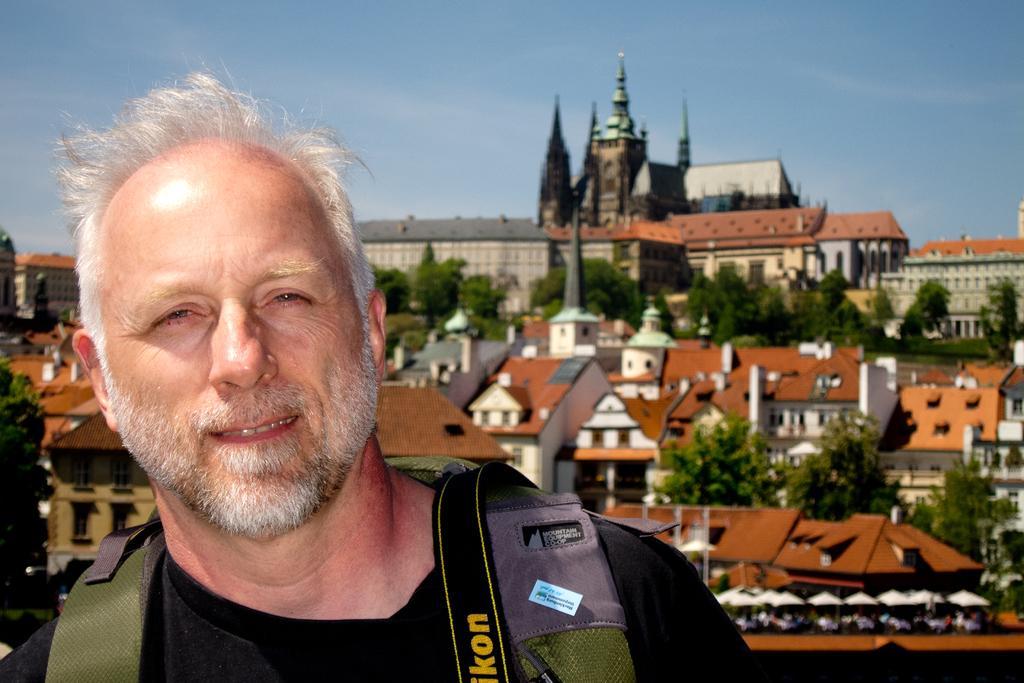How would you summarize this image in a sentence or two? In this image on the foreground there is a man wearing black t-shirt, carrying a bag. In the background there are buildings, trees, sky. 